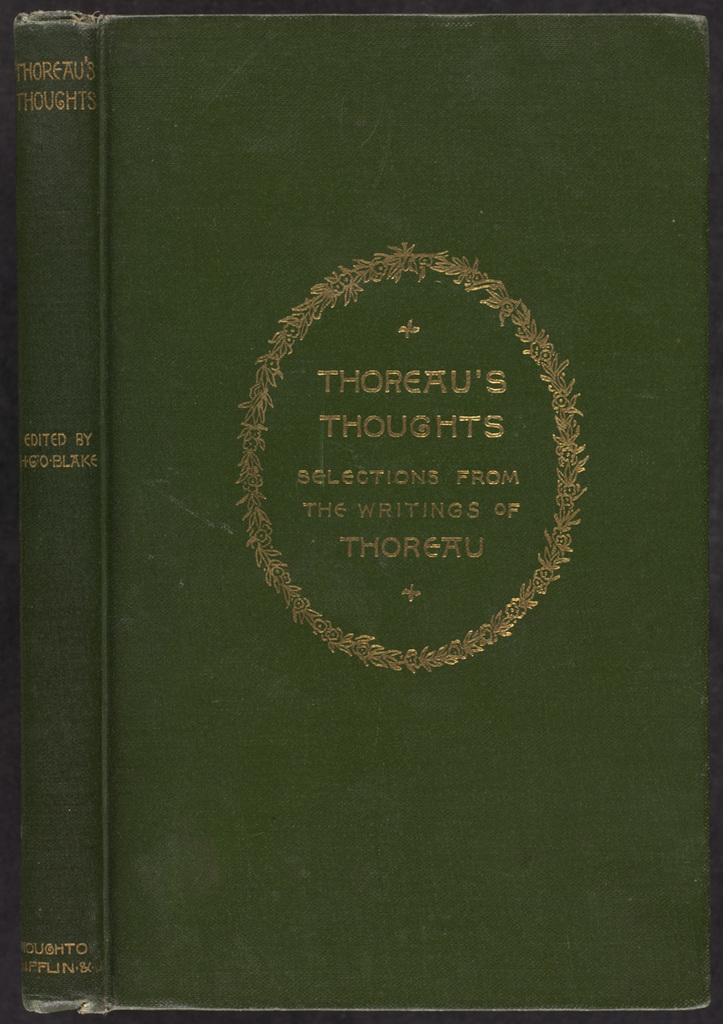Provide a one-sentence caption for the provided image. A green slightly frayed book titled Thoreau's thoughts. 